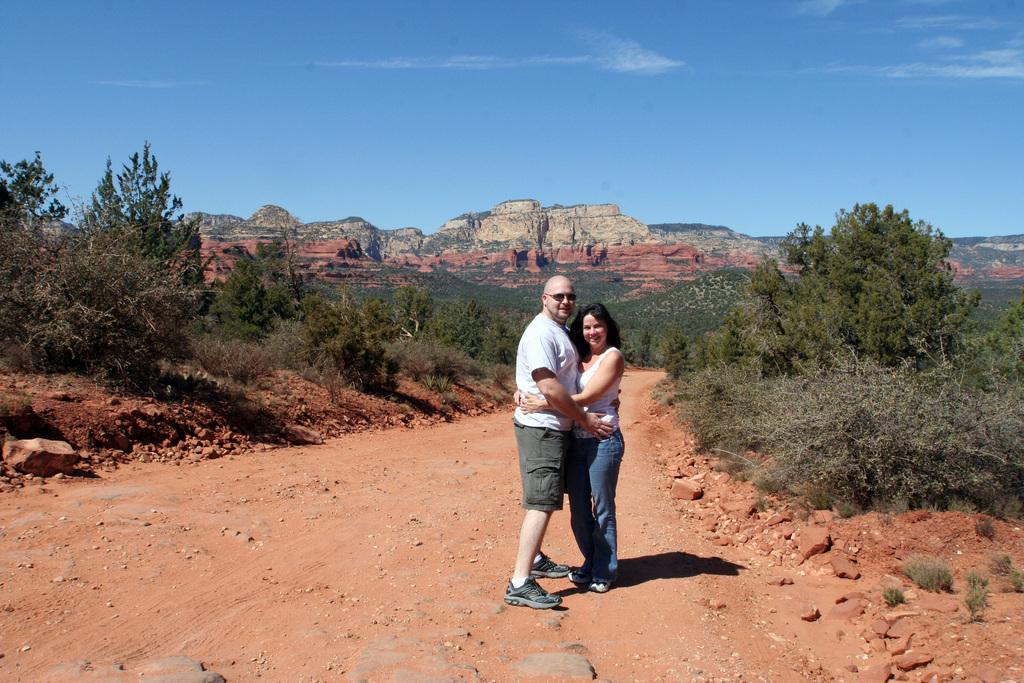How many people are in the image? There are two persons standing in the image. What is the facial expression of the persons in the image? The persons are smiling. What type of natural elements can be seen in the image? There are trees, plants, stones, and hills visible in the image. What is visible in the background of the image? The sky is visible in the background of the image, and there are clouds present in the sky. What type of lock can be seen on the trees in the image? There are no locks present on the trees in the image. What is the dirt content of the plants in the image? The provided facts do not mention the dirt content of the plants in the image. 